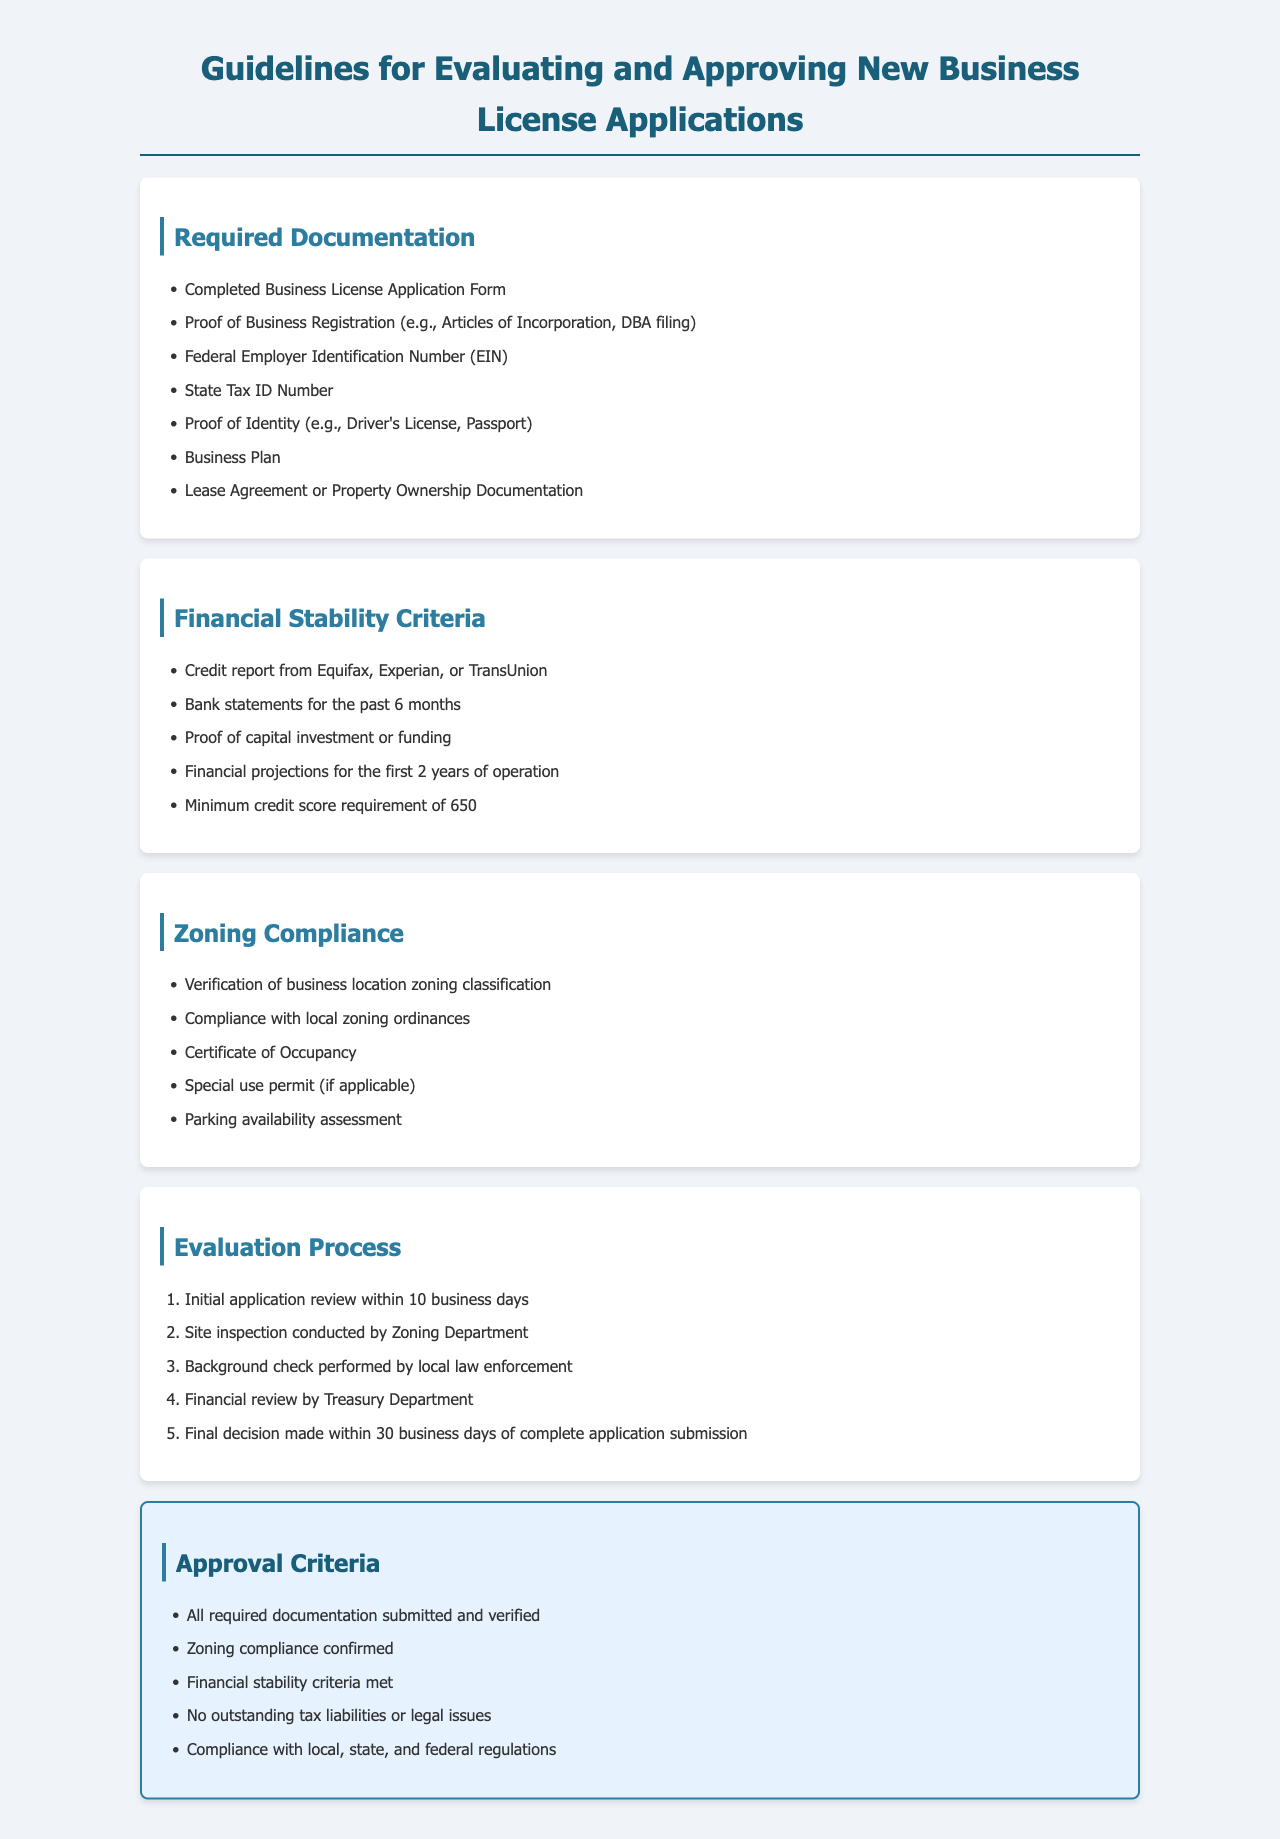What documentation is required for the business license application? The document specifies the required documentation listed in the "Required Documentation" section.
Answer: Completed Business License Application Form, Proof of Business Registration, Federal Employer Identification Number, State Tax ID Number, Proof of Identity, Business Plan, Lease Agreement or Property Ownership Documentation What is the minimum credit score requirement for financial stability? The minimum credit score requirement is mentioned in the "Financial Stability Criteria" section.
Answer: 650 What is the time frame for an initial application review? The time frame for initial application review is given in the "Evaluation Process" section.
Answer: 10 business days What must be verified for zoning compliance? The document describes zoning compliance requirements listed under "Zoning Compliance."
Answer: Verification of business location zoning classification How many financial projections are required for the first years of operation? The number of financial projections is mentioned in the "Financial Stability Criteria" section.
Answer: 2 years What is the total number of approval criteria listed? The total number of approval criteria can be counted from the "Approval Criteria" section.
Answer: 5 criteria Which department conducts the site inspection? The department responsible for the site inspection is specified in the "Evaluation Process."
Answer: Zoning Department What is needed if zoning compliance is not met? The document indicates this situation in the "Zoning Compliance" section.
Answer: Special use permit (if applicable) 